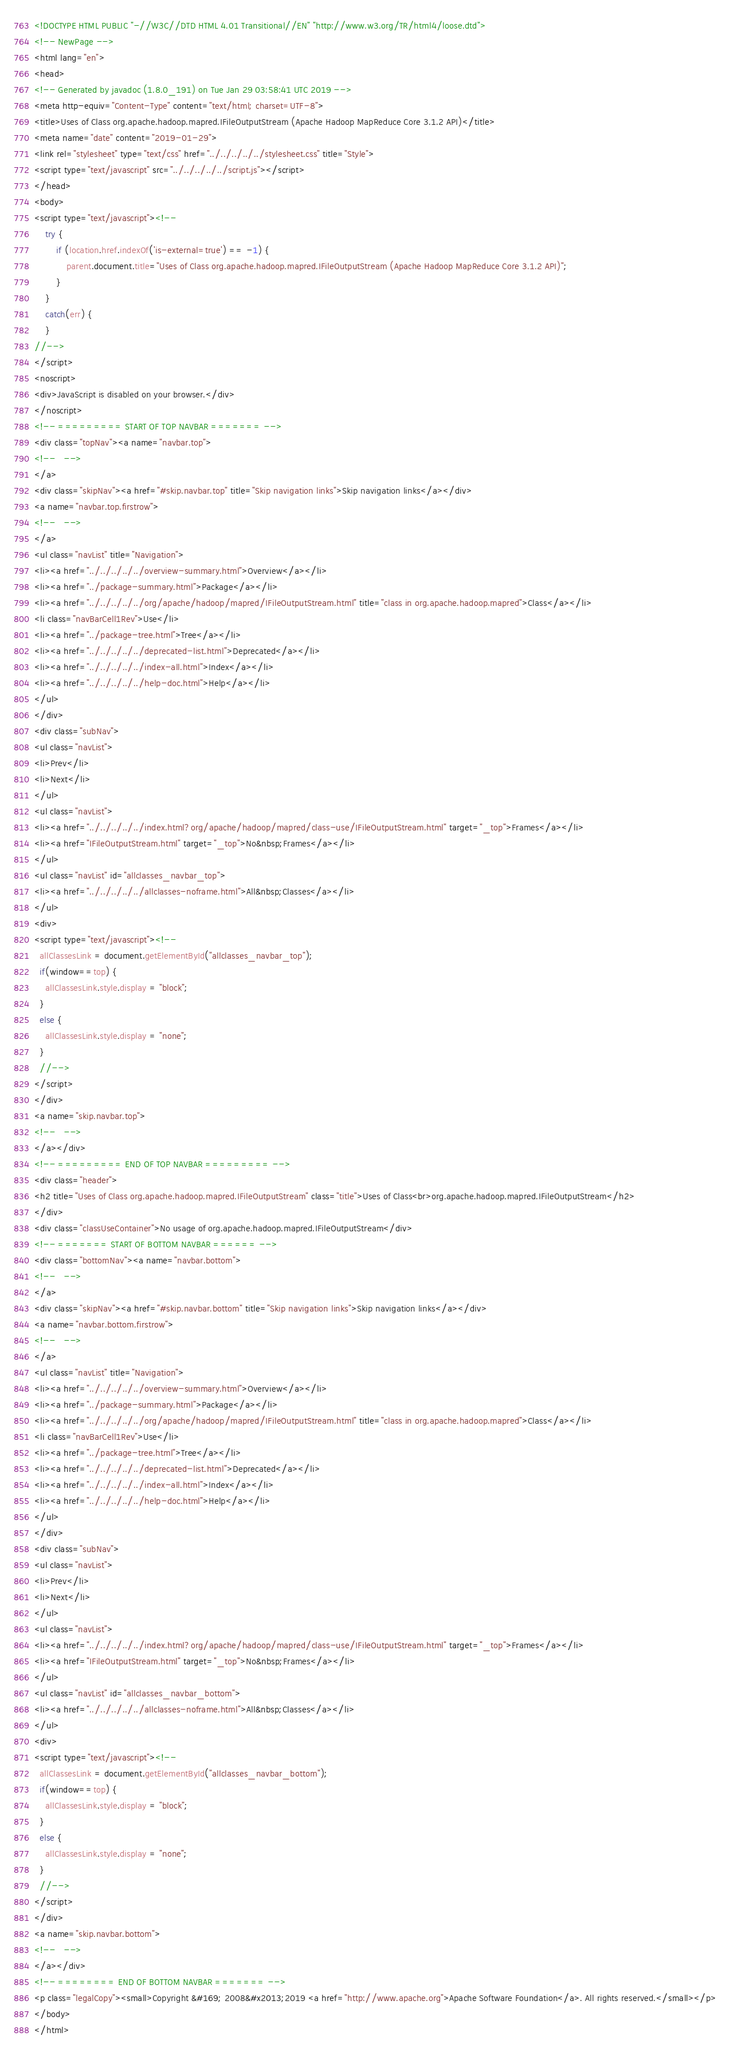<code> <loc_0><loc_0><loc_500><loc_500><_HTML_><!DOCTYPE HTML PUBLIC "-//W3C//DTD HTML 4.01 Transitional//EN" "http://www.w3.org/TR/html4/loose.dtd">
<!-- NewPage -->
<html lang="en">
<head>
<!-- Generated by javadoc (1.8.0_191) on Tue Jan 29 03:58:41 UTC 2019 -->
<meta http-equiv="Content-Type" content="text/html; charset=UTF-8">
<title>Uses of Class org.apache.hadoop.mapred.IFileOutputStream (Apache Hadoop MapReduce Core 3.1.2 API)</title>
<meta name="date" content="2019-01-29">
<link rel="stylesheet" type="text/css" href="../../../../../stylesheet.css" title="Style">
<script type="text/javascript" src="../../../../../script.js"></script>
</head>
<body>
<script type="text/javascript"><!--
    try {
        if (location.href.indexOf('is-external=true') == -1) {
            parent.document.title="Uses of Class org.apache.hadoop.mapred.IFileOutputStream (Apache Hadoop MapReduce Core 3.1.2 API)";
        }
    }
    catch(err) {
    }
//-->
</script>
<noscript>
<div>JavaScript is disabled on your browser.</div>
</noscript>
<!-- ========= START OF TOP NAVBAR ======= -->
<div class="topNav"><a name="navbar.top">
<!--   -->
</a>
<div class="skipNav"><a href="#skip.navbar.top" title="Skip navigation links">Skip navigation links</a></div>
<a name="navbar.top.firstrow">
<!--   -->
</a>
<ul class="navList" title="Navigation">
<li><a href="../../../../../overview-summary.html">Overview</a></li>
<li><a href="../package-summary.html">Package</a></li>
<li><a href="../../../../../org/apache/hadoop/mapred/IFileOutputStream.html" title="class in org.apache.hadoop.mapred">Class</a></li>
<li class="navBarCell1Rev">Use</li>
<li><a href="../package-tree.html">Tree</a></li>
<li><a href="../../../../../deprecated-list.html">Deprecated</a></li>
<li><a href="../../../../../index-all.html">Index</a></li>
<li><a href="../../../../../help-doc.html">Help</a></li>
</ul>
</div>
<div class="subNav">
<ul class="navList">
<li>Prev</li>
<li>Next</li>
</ul>
<ul class="navList">
<li><a href="../../../../../index.html?org/apache/hadoop/mapred/class-use/IFileOutputStream.html" target="_top">Frames</a></li>
<li><a href="IFileOutputStream.html" target="_top">No&nbsp;Frames</a></li>
</ul>
<ul class="navList" id="allclasses_navbar_top">
<li><a href="../../../../../allclasses-noframe.html">All&nbsp;Classes</a></li>
</ul>
<div>
<script type="text/javascript"><!--
  allClassesLink = document.getElementById("allclasses_navbar_top");
  if(window==top) {
    allClassesLink.style.display = "block";
  }
  else {
    allClassesLink.style.display = "none";
  }
  //-->
</script>
</div>
<a name="skip.navbar.top">
<!--   -->
</a></div>
<!-- ========= END OF TOP NAVBAR ========= -->
<div class="header">
<h2 title="Uses of Class org.apache.hadoop.mapred.IFileOutputStream" class="title">Uses of Class<br>org.apache.hadoop.mapred.IFileOutputStream</h2>
</div>
<div class="classUseContainer">No usage of org.apache.hadoop.mapred.IFileOutputStream</div>
<!-- ======= START OF BOTTOM NAVBAR ====== -->
<div class="bottomNav"><a name="navbar.bottom">
<!--   -->
</a>
<div class="skipNav"><a href="#skip.navbar.bottom" title="Skip navigation links">Skip navigation links</a></div>
<a name="navbar.bottom.firstrow">
<!--   -->
</a>
<ul class="navList" title="Navigation">
<li><a href="../../../../../overview-summary.html">Overview</a></li>
<li><a href="../package-summary.html">Package</a></li>
<li><a href="../../../../../org/apache/hadoop/mapred/IFileOutputStream.html" title="class in org.apache.hadoop.mapred">Class</a></li>
<li class="navBarCell1Rev">Use</li>
<li><a href="../package-tree.html">Tree</a></li>
<li><a href="../../../../../deprecated-list.html">Deprecated</a></li>
<li><a href="../../../../../index-all.html">Index</a></li>
<li><a href="../../../../../help-doc.html">Help</a></li>
</ul>
</div>
<div class="subNav">
<ul class="navList">
<li>Prev</li>
<li>Next</li>
</ul>
<ul class="navList">
<li><a href="../../../../../index.html?org/apache/hadoop/mapred/class-use/IFileOutputStream.html" target="_top">Frames</a></li>
<li><a href="IFileOutputStream.html" target="_top">No&nbsp;Frames</a></li>
</ul>
<ul class="navList" id="allclasses_navbar_bottom">
<li><a href="../../../../../allclasses-noframe.html">All&nbsp;Classes</a></li>
</ul>
<div>
<script type="text/javascript"><!--
  allClassesLink = document.getElementById("allclasses_navbar_bottom");
  if(window==top) {
    allClassesLink.style.display = "block";
  }
  else {
    allClassesLink.style.display = "none";
  }
  //-->
</script>
</div>
<a name="skip.navbar.bottom">
<!--   -->
</a></div>
<!-- ======== END OF BOTTOM NAVBAR ======= -->
<p class="legalCopy"><small>Copyright &#169; 2008&#x2013;2019 <a href="http://www.apache.org">Apache Software Foundation</a>. All rights reserved.</small></p>
</body>
</html>
</code> 